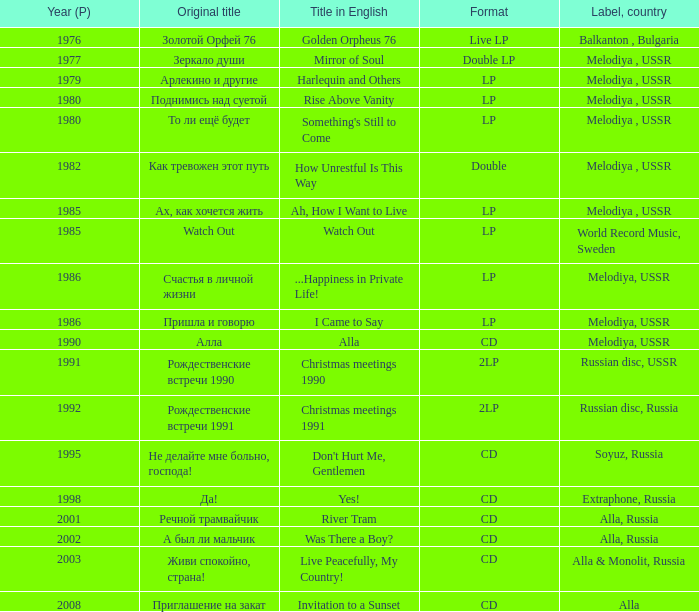What is the english title in lp version and the original title of "то ли ещё будет"? Something's Still to Come. 